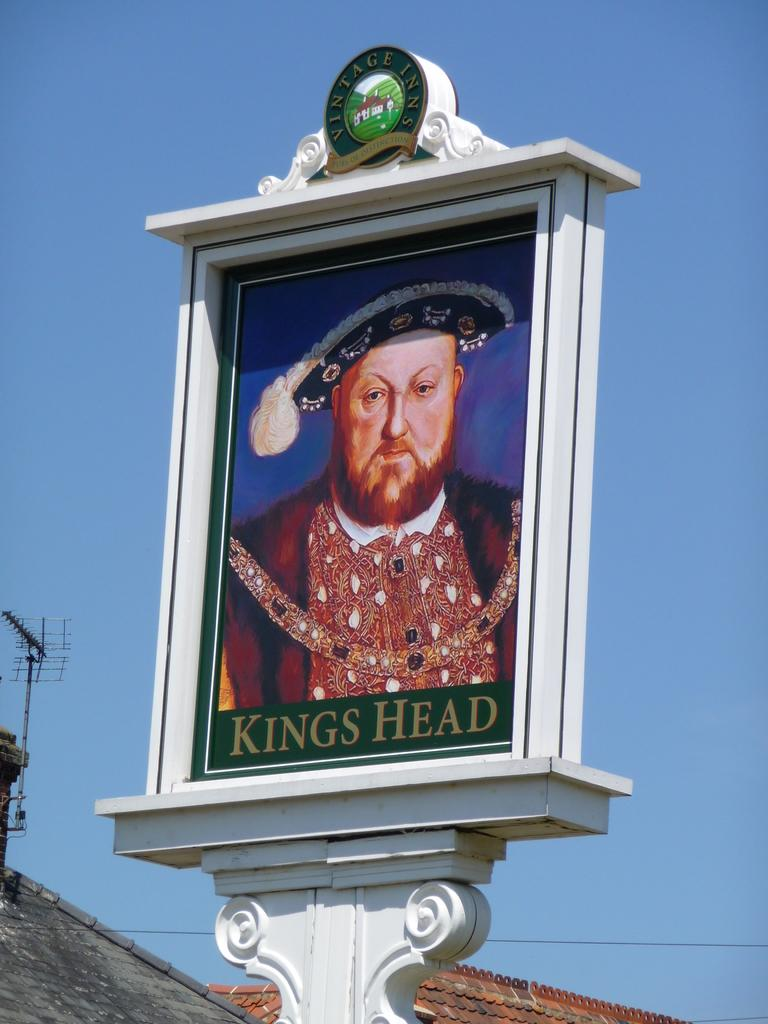What object in the image contains an image of a person? The picture frame in the image contains an image of a person. What can be seen on top of the building in the image? There is an antenna visible in the image, and it is on a building. What substance is being plotted on the scale in the image? There is no substance being plotted on a scale in the image; the facts provided do not mention a scale or any substance. 